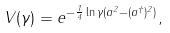<formula> <loc_0><loc_0><loc_500><loc_500>V ( \gamma ) = e ^ { - \frac { 1 } { 4 } \ln \gamma ( a ^ { 2 } - ( a ^ { \dagger } ) ^ { 2 } ) } ,</formula> 